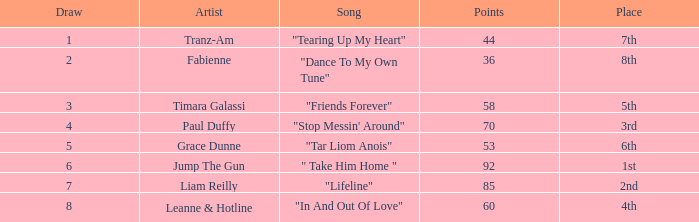What's the usual number of listeners for the song "stop messin' around"? 4.0. Could you parse the entire table? {'header': ['Draw', 'Artist', 'Song', 'Points', 'Place'], 'rows': [['1', 'Tranz-Am', '"Tearing Up My Heart"', '44', '7th'], ['2', 'Fabienne', '"Dance To My Own Tune"', '36', '8th'], ['3', 'Timara Galassi', '"Friends Forever"', '58', '5th'], ['4', 'Paul Duffy', '"Stop Messin\' Around"', '70', '3rd'], ['5', 'Grace Dunne', '"Tar Liom Anois"', '53', '6th'], ['6', 'Jump The Gun', '" Take Him Home "', '92', '1st'], ['7', 'Liam Reilly', '"Lifeline"', '85', '2nd'], ['8', 'Leanne & Hotline', '"In And Out Of Love"', '60', '4th']]} 